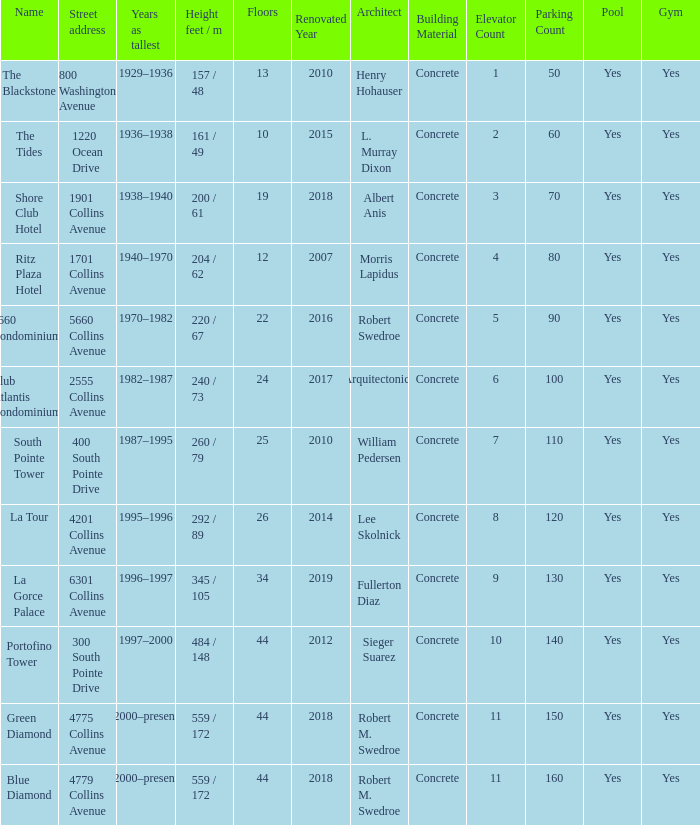What is the height of the Tides with less than 34 floors? 161 / 49. 